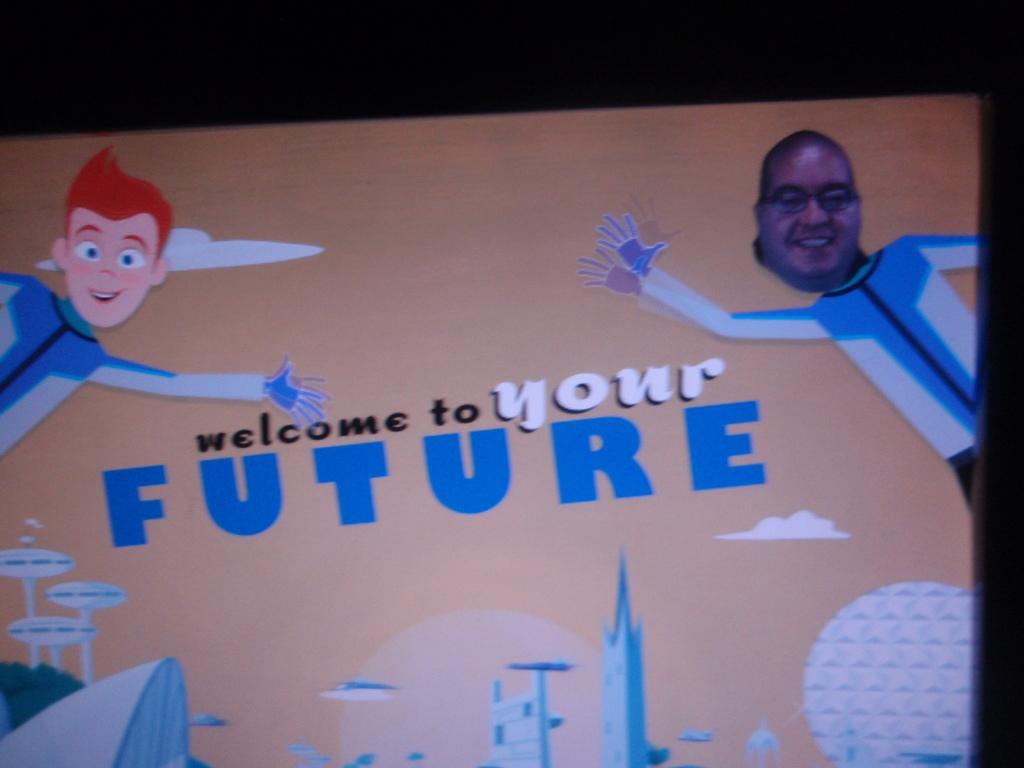Could you give a brief overview of what you see in this image? In this image we can see a board. On the board there are some pictures and text. The background of the image is dark. 